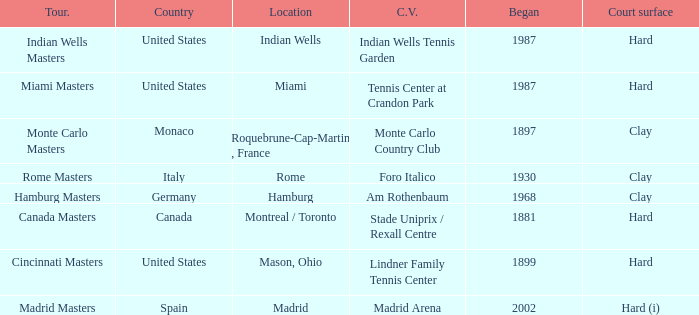What is the current venue for the Miami Masters tournament? Tennis Center at Crandon Park. 